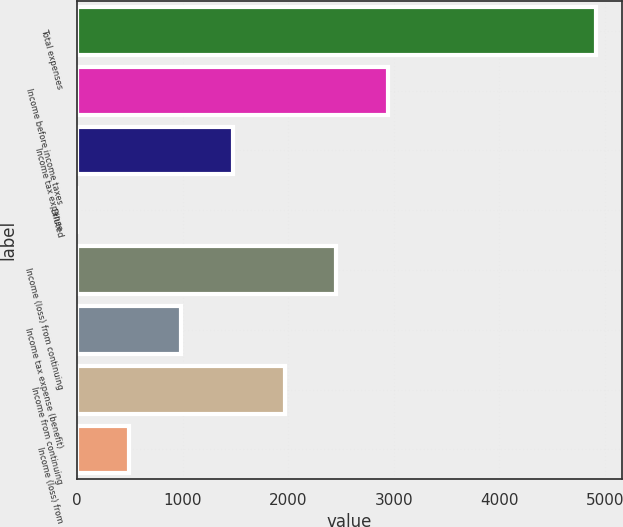Convert chart to OTSL. <chart><loc_0><loc_0><loc_500><loc_500><bar_chart><fcel>Total expenses<fcel>Income before income taxes<fcel>Income tax expense<fcel>Diluted<fcel>Income (loss) from continuing<fcel>Income tax expense (benefit)<fcel>Income from continuing<fcel>Income (loss) from<nl><fcel>4911<fcel>2947.12<fcel>1474.24<fcel>1.36<fcel>2456.16<fcel>983.28<fcel>1965.2<fcel>492.32<nl></chart> 